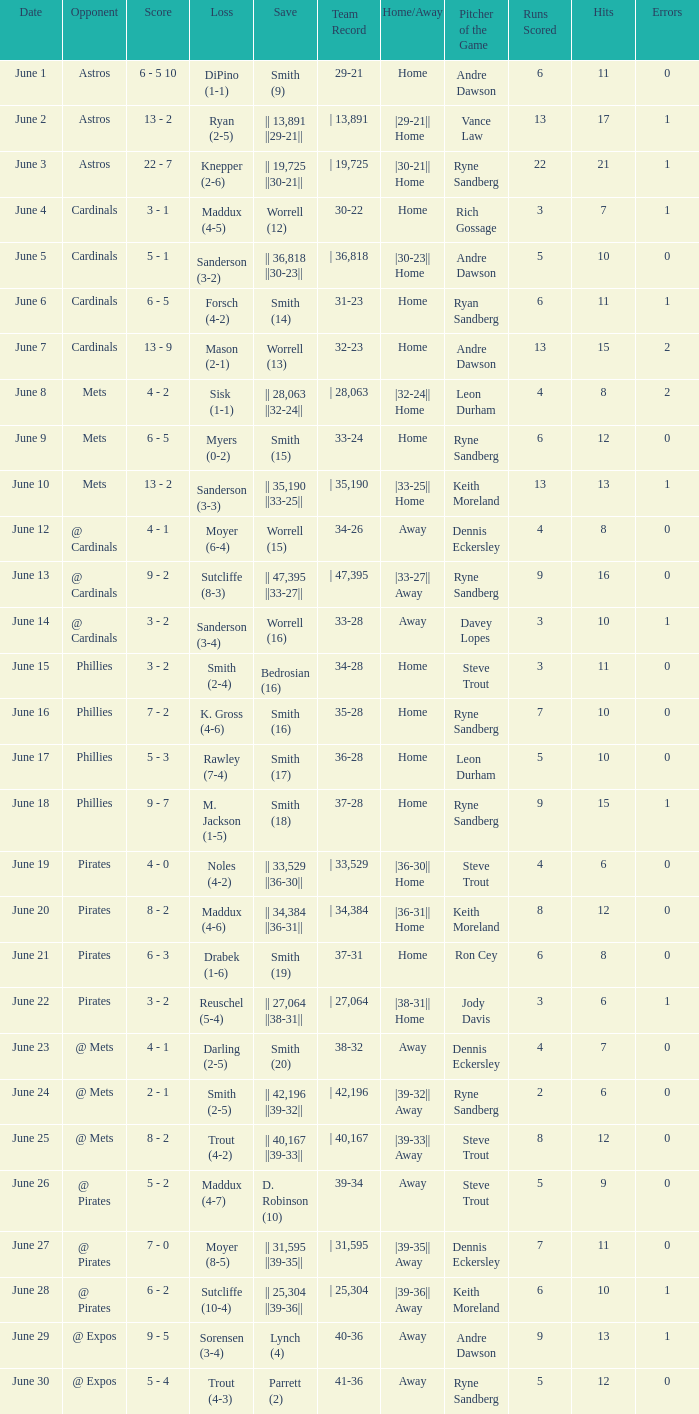When did the chicago cubs encounter a 4-2 trout defeat? June 25. 